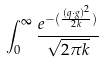Convert formula to latex. <formula><loc_0><loc_0><loc_500><loc_500>\int _ { 0 } ^ { \infty } \frac { e ^ { - ( \frac { ( q \cdot g ) ^ { 2 } } { 2 k } ) } } { \sqrt { 2 \pi k } }</formula> 